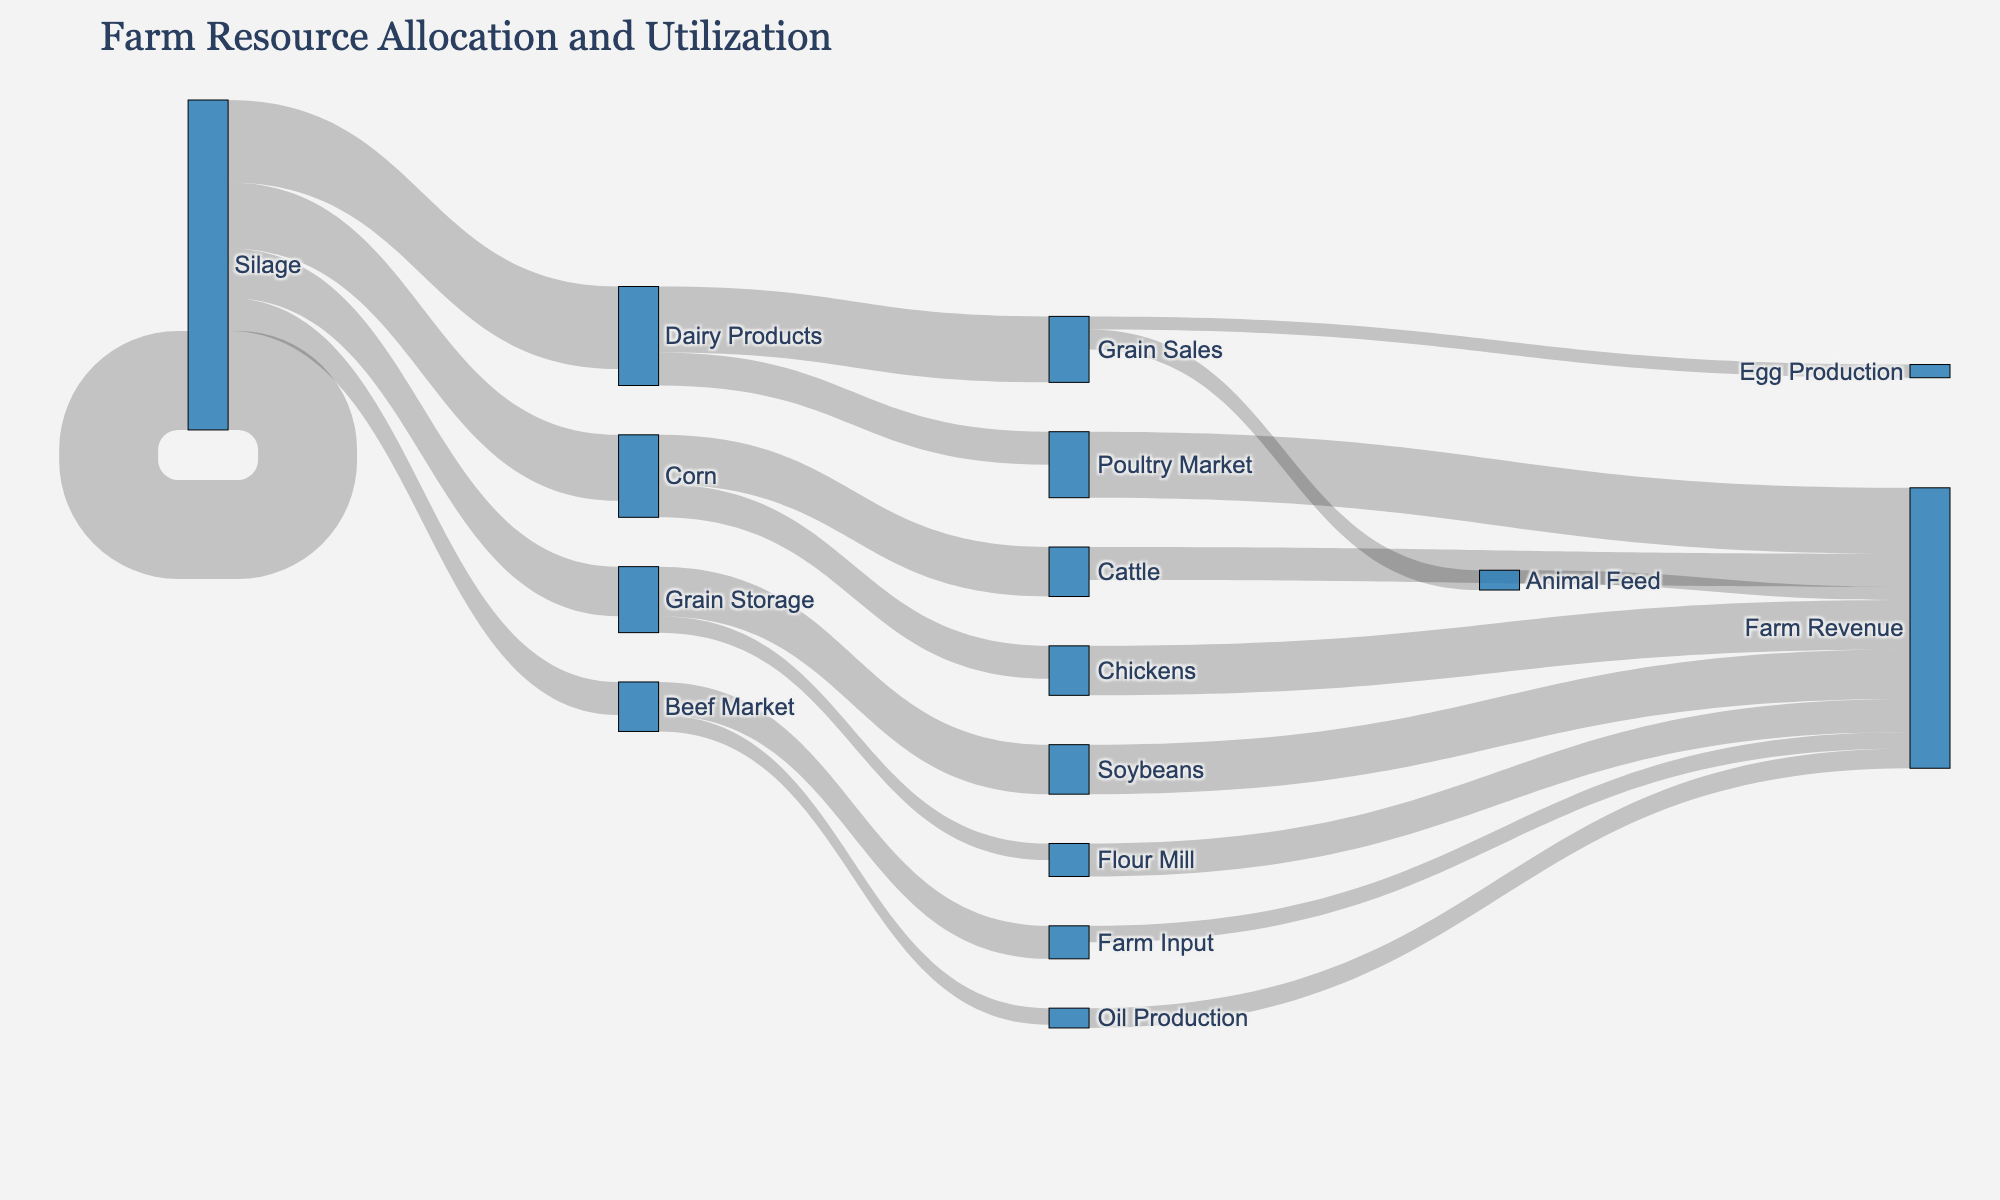What is the title of the diagram? The title is usually located at the top of the diagram and is used to describe the main subject of the visual representation. Here, it’s "Farm Resource Allocation and Utilization."
Answer: Farm Resource Allocation and Utilization How many farm inputs are shown in the diagram? The farm inputs can be identified by tracing the lines that originate from the source labeled "Farm Input." The categories that follow from it are Corn, Soybeans, Wheat, Cattle, and Chickens, making a total of five farm inputs.
Answer: 5 Which crop receives the highest allocation of farm inputs, and how much is it? By examining the values of the arrows originating from "Farm Input," we can see that Corn receives the highest allocation with a value of 30 units.
Answer: Corn, 30 What is the total contribution to Farm Revenue from Egg Production and Poultry Market? To find the total contribution, sum the values for Egg Production (6) and Poultry Market (4), which gives us 10 units.
Answer: 10 Which outputs are contributing to Farm Revenue from Soybeans, and what is their total value? From the diagram, the outputs from Soybeans are Oil Production (15 units) and Animal Feed (10 units). Summing these values gives a total of 25 units.
Answer: Oil Production, Animal Feed, 25 Between Grain Sales and Flour Mill, which one generates more revenue? By comparing the values linked to Farm Revenue from Grain Sales and Flour Mill, we see that both contribute 20 and 15 units respectively. Grain Sales generates more revenue.
Answer: Grain Sales What is the smallest contribution to Farm Revenue, and from which source does it come? By reviewing all links that contribute to Farm Revenue, the smallest value is 4 units, coming from Poultry Market.
Answer: Poultry Market, 4 How much of the Corn is sold as Grain Sales? Follow the link from Corn to Grain Sales, which shows a value of 20 units.
Answer: 20 units What is the total amount of farm input allocated to livestock (Cattle and Chickens)? By summing the values for Cattle (15) and Chickens (10), the total farm input for livestock is 25 units.
Answer: 25 units Based on the diagram, what is the combined revenue from Silage and Beef Market? The contribution to Farm Revenue from Silage is 10 units, and from the Beef Market is also 10 units, making the combined revenue 20 units.
Answer: 20 units 